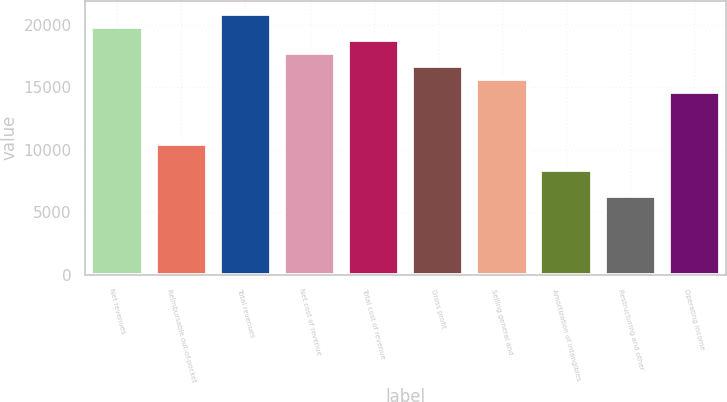Convert chart. <chart><loc_0><loc_0><loc_500><loc_500><bar_chart><fcel>Net revenues<fcel>Reimbursable out-of-pocket<fcel>Total revenues<fcel>Net cost of revenue<fcel>Total cost of revenue<fcel>Gross profit<fcel>Selling general and<fcel>Amortization of intangibles<fcel>Restructuring and other<fcel>Operating income<nl><fcel>19836.8<fcel>10441.4<fcel>20880.7<fcel>17748.9<fcel>18792.8<fcel>16705<fcel>15661<fcel>8353.54<fcel>6265.68<fcel>14617.1<nl></chart> 